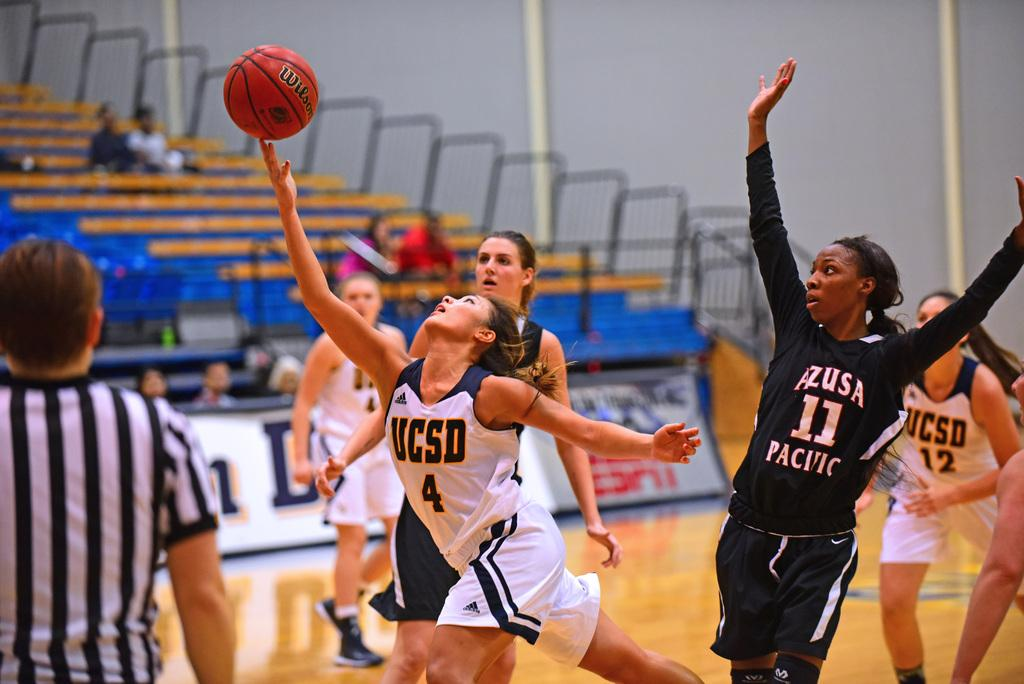<image>
Write a terse but informative summary of the picture. Women's college basket ball game between UCSD and AZUSA PACIFIC, players reach for the ball as a referee watches. 